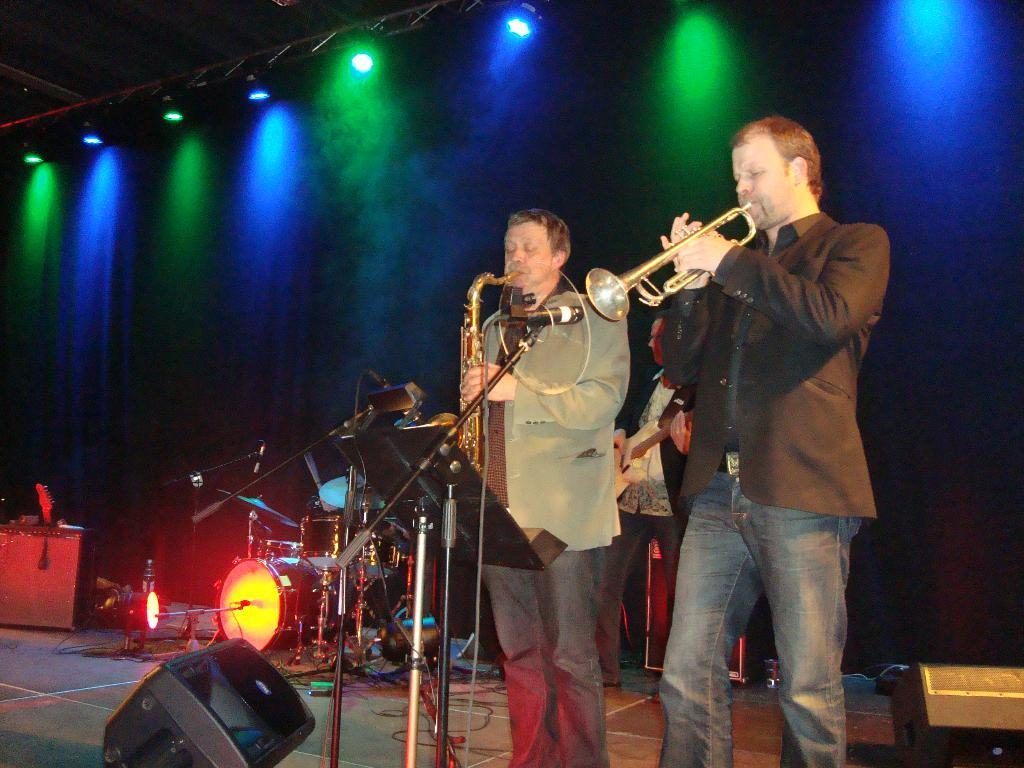How many people are in the image? There are three people in the image. What are the people doing in the image? The people are standing and holding musical instruments. What equipment is visible in the image that is related to music? There are microphones and a drum set visible in the image. What can be seen in the background of the image? There are lights in the background of the image. What type of zebra can be seen in the image? There is no zebra present in the image. What level of difficulty is the cast performing at in the image? There is no cast performing in the image, and therefore no level of difficulty can be determined. 